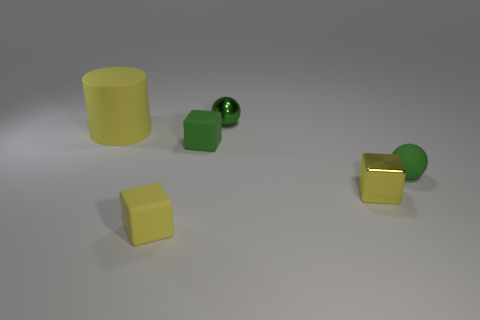What shape is the big thing that is made of the same material as the green cube?
Your response must be concise. Cylinder. Are there fewer green cubes than purple blocks?
Your answer should be compact. No. Do the big yellow cylinder and the small green cube have the same material?
Ensure brevity in your answer.  Yes. How many other objects are there of the same color as the tiny metallic block?
Give a very brief answer. 2. Is the number of yellow blocks greater than the number of small metal blocks?
Offer a terse response. Yes. Does the yellow metal thing have the same size as the green rubber object that is behind the green matte sphere?
Your answer should be compact. Yes. There is a cube that is on the right side of the green metallic ball; what is its color?
Your answer should be compact. Yellow. What number of cyan things are either large things or shiny blocks?
Your answer should be compact. 0. The big matte cylinder has what color?
Provide a succinct answer. Yellow. Are there any other things that have the same material as the tiny green block?
Offer a terse response. Yes. 